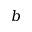Convert formula to latex. <formula><loc_0><loc_0><loc_500><loc_500>b</formula> 